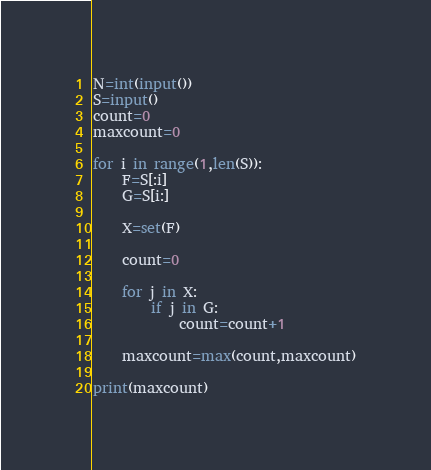<code> <loc_0><loc_0><loc_500><loc_500><_Python_>N=int(input())
S=input()
count=0
maxcount=0

for i in range(1,len(S)):
    F=S[:i]
    G=S[i:]

    X=set(F)

    count=0

    for j in X:
        if j in G:
            count=count+1

    maxcount=max(count,maxcount)

print(maxcount)
</code> 